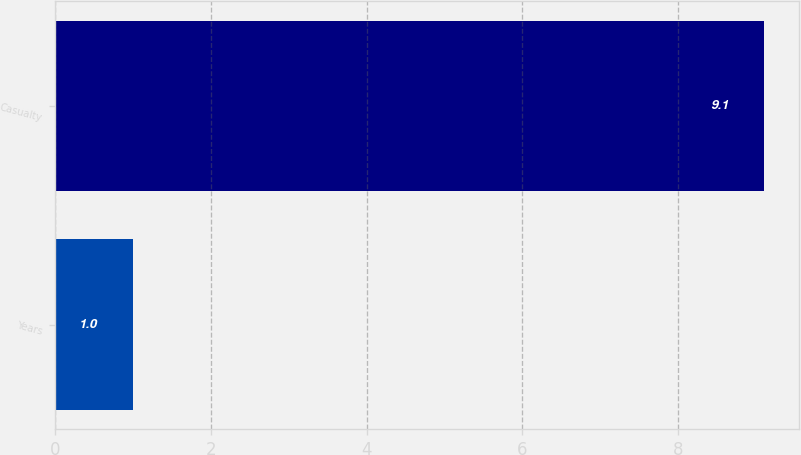Convert chart to OTSL. <chart><loc_0><loc_0><loc_500><loc_500><bar_chart><fcel>Years<fcel>Casualty<nl><fcel>1<fcel>9.1<nl></chart> 